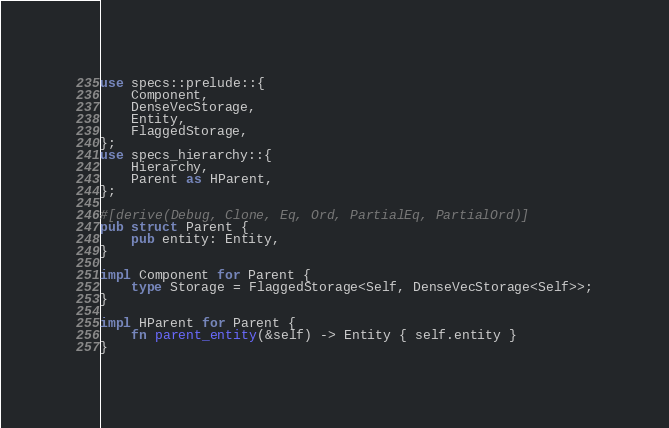Convert code to text. <code><loc_0><loc_0><loc_500><loc_500><_Rust_>use specs::prelude::{
	Component,
	DenseVecStorage,
	Entity,
	FlaggedStorage,
};
use specs_hierarchy::{
	Hierarchy,
	Parent as HParent,
};

#[derive(Debug, Clone, Eq, Ord, PartialEq, PartialOrd)]
pub struct Parent {
    pub entity: Entity,
}

impl Component for Parent {
	type Storage = FlaggedStorage<Self, DenseVecStorage<Self>>;
}

impl HParent for Parent {
	fn parent_entity(&self) -> Entity { self.entity }
}</code> 